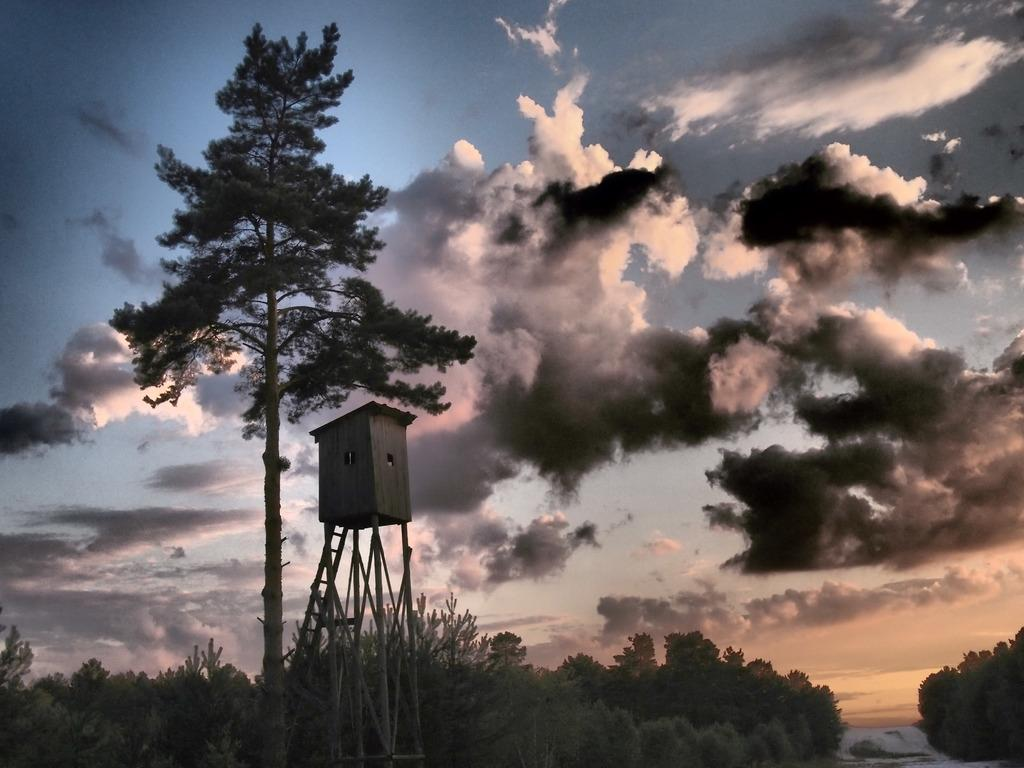What type of natural element can be seen in the image? There is a tree in the image. What type of structure is located towards the left side of the image? There is a wooden house towards the left side of the image. What type of vegetation is present at the bottom of the image? There are trees at the bottom of the image. What is visible in the background of the image? There is a sky visible in the background of the image. What can be observed in the sky? Clouds are present in the sky. What color is the ladybug on the sweater in the image? There is no ladybug or sweater present in the image. Can you provide an example of a similar scene to the one depicted in the image? The image is unique, and there is no example of a similar scene provided. 